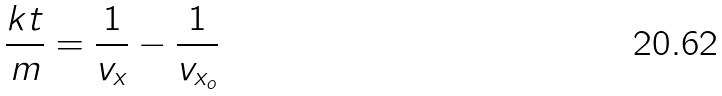<formula> <loc_0><loc_0><loc_500><loc_500>\frac { k t } { m } = \frac { 1 } { v _ { x } } - \frac { 1 } { v _ { x _ { o } } }</formula> 